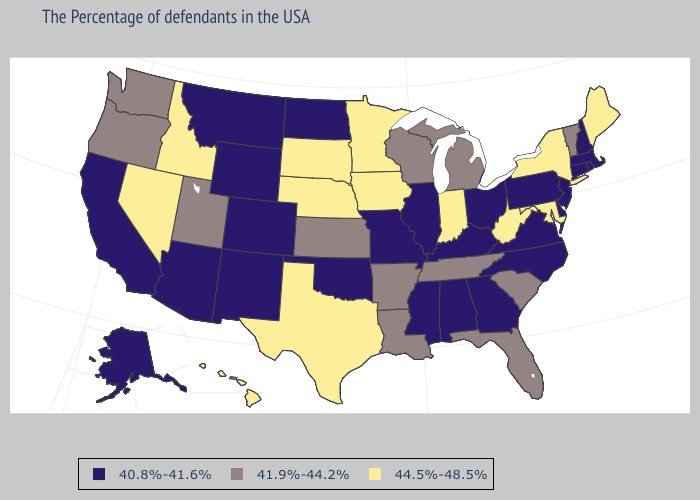Name the states that have a value in the range 40.8%-41.6%?
Concise answer only. Massachusetts, Rhode Island, New Hampshire, Connecticut, New Jersey, Delaware, Pennsylvania, Virginia, North Carolina, Ohio, Georgia, Kentucky, Alabama, Illinois, Mississippi, Missouri, Oklahoma, North Dakota, Wyoming, Colorado, New Mexico, Montana, Arizona, California, Alaska. Name the states that have a value in the range 44.5%-48.5%?
Short answer required. Maine, New York, Maryland, West Virginia, Indiana, Minnesota, Iowa, Nebraska, Texas, South Dakota, Idaho, Nevada, Hawaii. What is the highest value in states that border North Dakota?
Keep it brief. 44.5%-48.5%. What is the value of Indiana?
Keep it brief. 44.5%-48.5%. What is the highest value in states that border Utah?
Write a very short answer. 44.5%-48.5%. What is the value of North Carolina?
Give a very brief answer. 40.8%-41.6%. Name the states that have a value in the range 40.8%-41.6%?
Quick response, please. Massachusetts, Rhode Island, New Hampshire, Connecticut, New Jersey, Delaware, Pennsylvania, Virginia, North Carolina, Ohio, Georgia, Kentucky, Alabama, Illinois, Mississippi, Missouri, Oklahoma, North Dakota, Wyoming, Colorado, New Mexico, Montana, Arizona, California, Alaska. What is the highest value in the USA?
Write a very short answer. 44.5%-48.5%. Among the states that border South Dakota , which have the highest value?
Quick response, please. Minnesota, Iowa, Nebraska. Among the states that border Tennessee , which have the lowest value?
Quick response, please. Virginia, North Carolina, Georgia, Kentucky, Alabama, Mississippi, Missouri. Does Texas have the lowest value in the South?
Give a very brief answer. No. Name the states that have a value in the range 41.9%-44.2%?
Keep it brief. Vermont, South Carolina, Florida, Michigan, Tennessee, Wisconsin, Louisiana, Arkansas, Kansas, Utah, Washington, Oregon. Among the states that border Oregon , does Nevada have the lowest value?
Give a very brief answer. No. Name the states that have a value in the range 41.9%-44.2%?
Give a very brief answer. Vermont, South Carolina, Florida, Michigan, Tennessee, Wisconsin, Louisiana, Arkansas, Kansas, Utah, Washington, Oregon. 